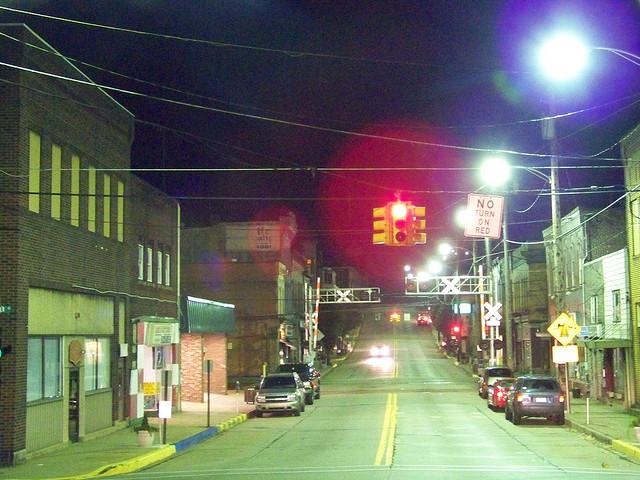Are the lights working?
Keep it brief. Yes. Is the pic very visible?
Answer briefly. Yes. What time of day is it?
Short answer required. Night. What color is the light?
Short answer required. Red. 